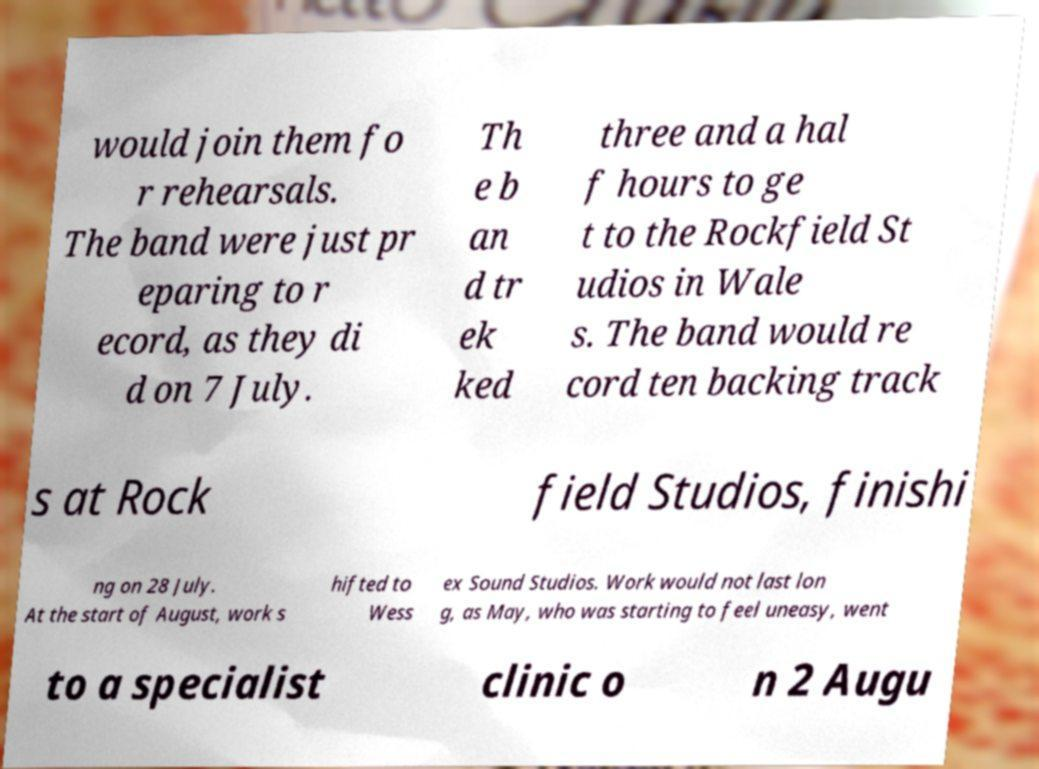Could you extract and type out the text from this image? would join them fo r rehearsals. The band were just pr eparing to r ecord, as they di d on 7 July. Th e b an d tr ek ked three and a hal f hours to ge t to the Rockfield St udios in Wale s. The band would re cord ten backing track s at Rock field Studios, finishi ng on 28 July. At the start of August, work s hifted to Wess ex Sound Studios. Work would not last lon g, as May, who was starting to feel uneasy, went to a specialist clinic o n 2 Augu 